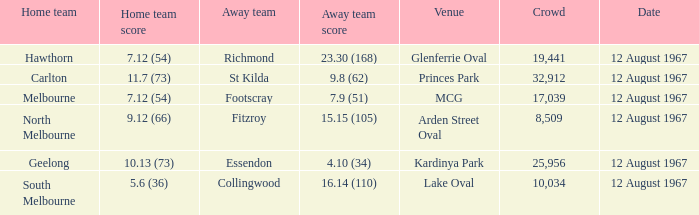What is the date of the game between Melbourne and Footscray? 12 August 1967. 